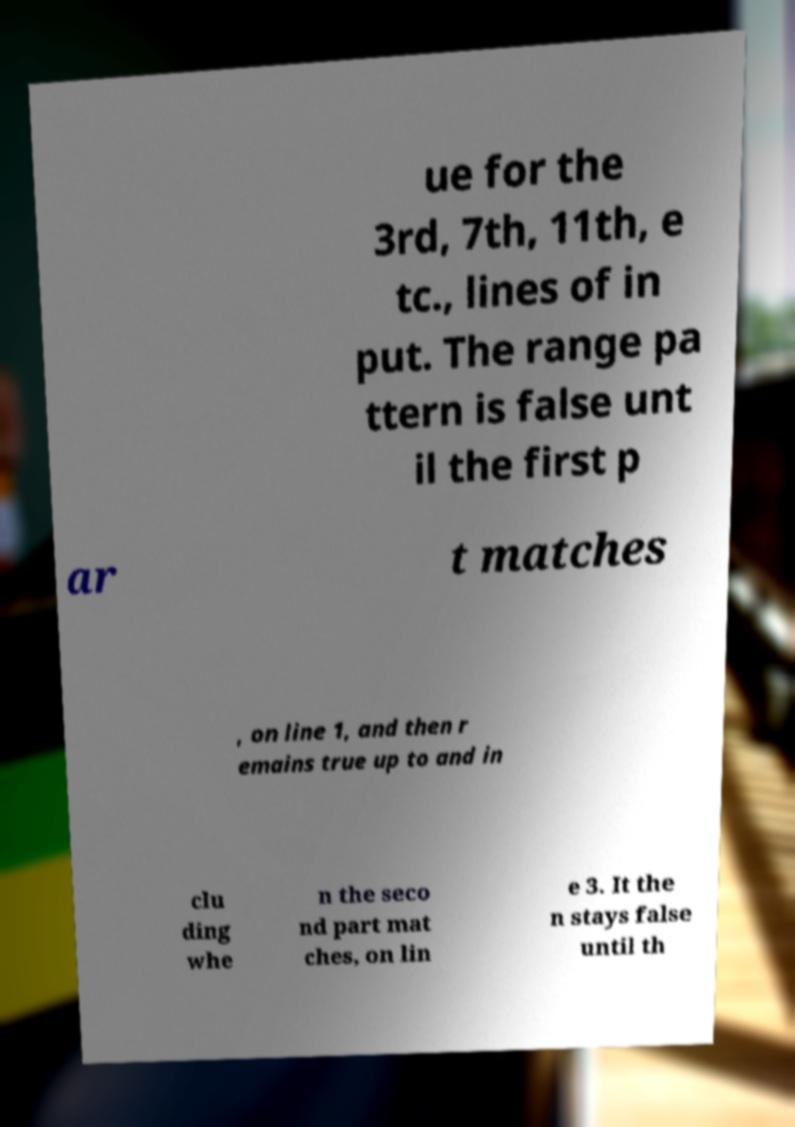Please identify and transcribe the text found in this image. ue for the 3rd, 7th, 11th, e tc., lines of in put. The range pa ttern is false unt il the first p ar t matches , on line 1, and then r emains true up to and in clu ding whe n the seco nd part mat ches, on lin e 3. It the n stays false until th 